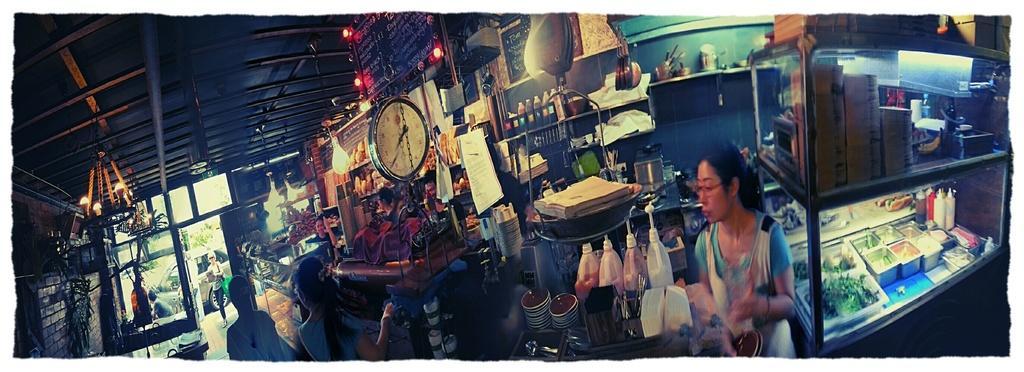Can you describe this image briefly? There are people and we can see bottles and objects on platform. We can see bottles, clothes and few things on shelves. In the background there are objects. On the right side of the image we can see bottles, containers and objects in glass racks. On the left side of the image we can see wall, candles with stand, objects on table, pole and glass. We can see car. At the top we can see lights and clock. 